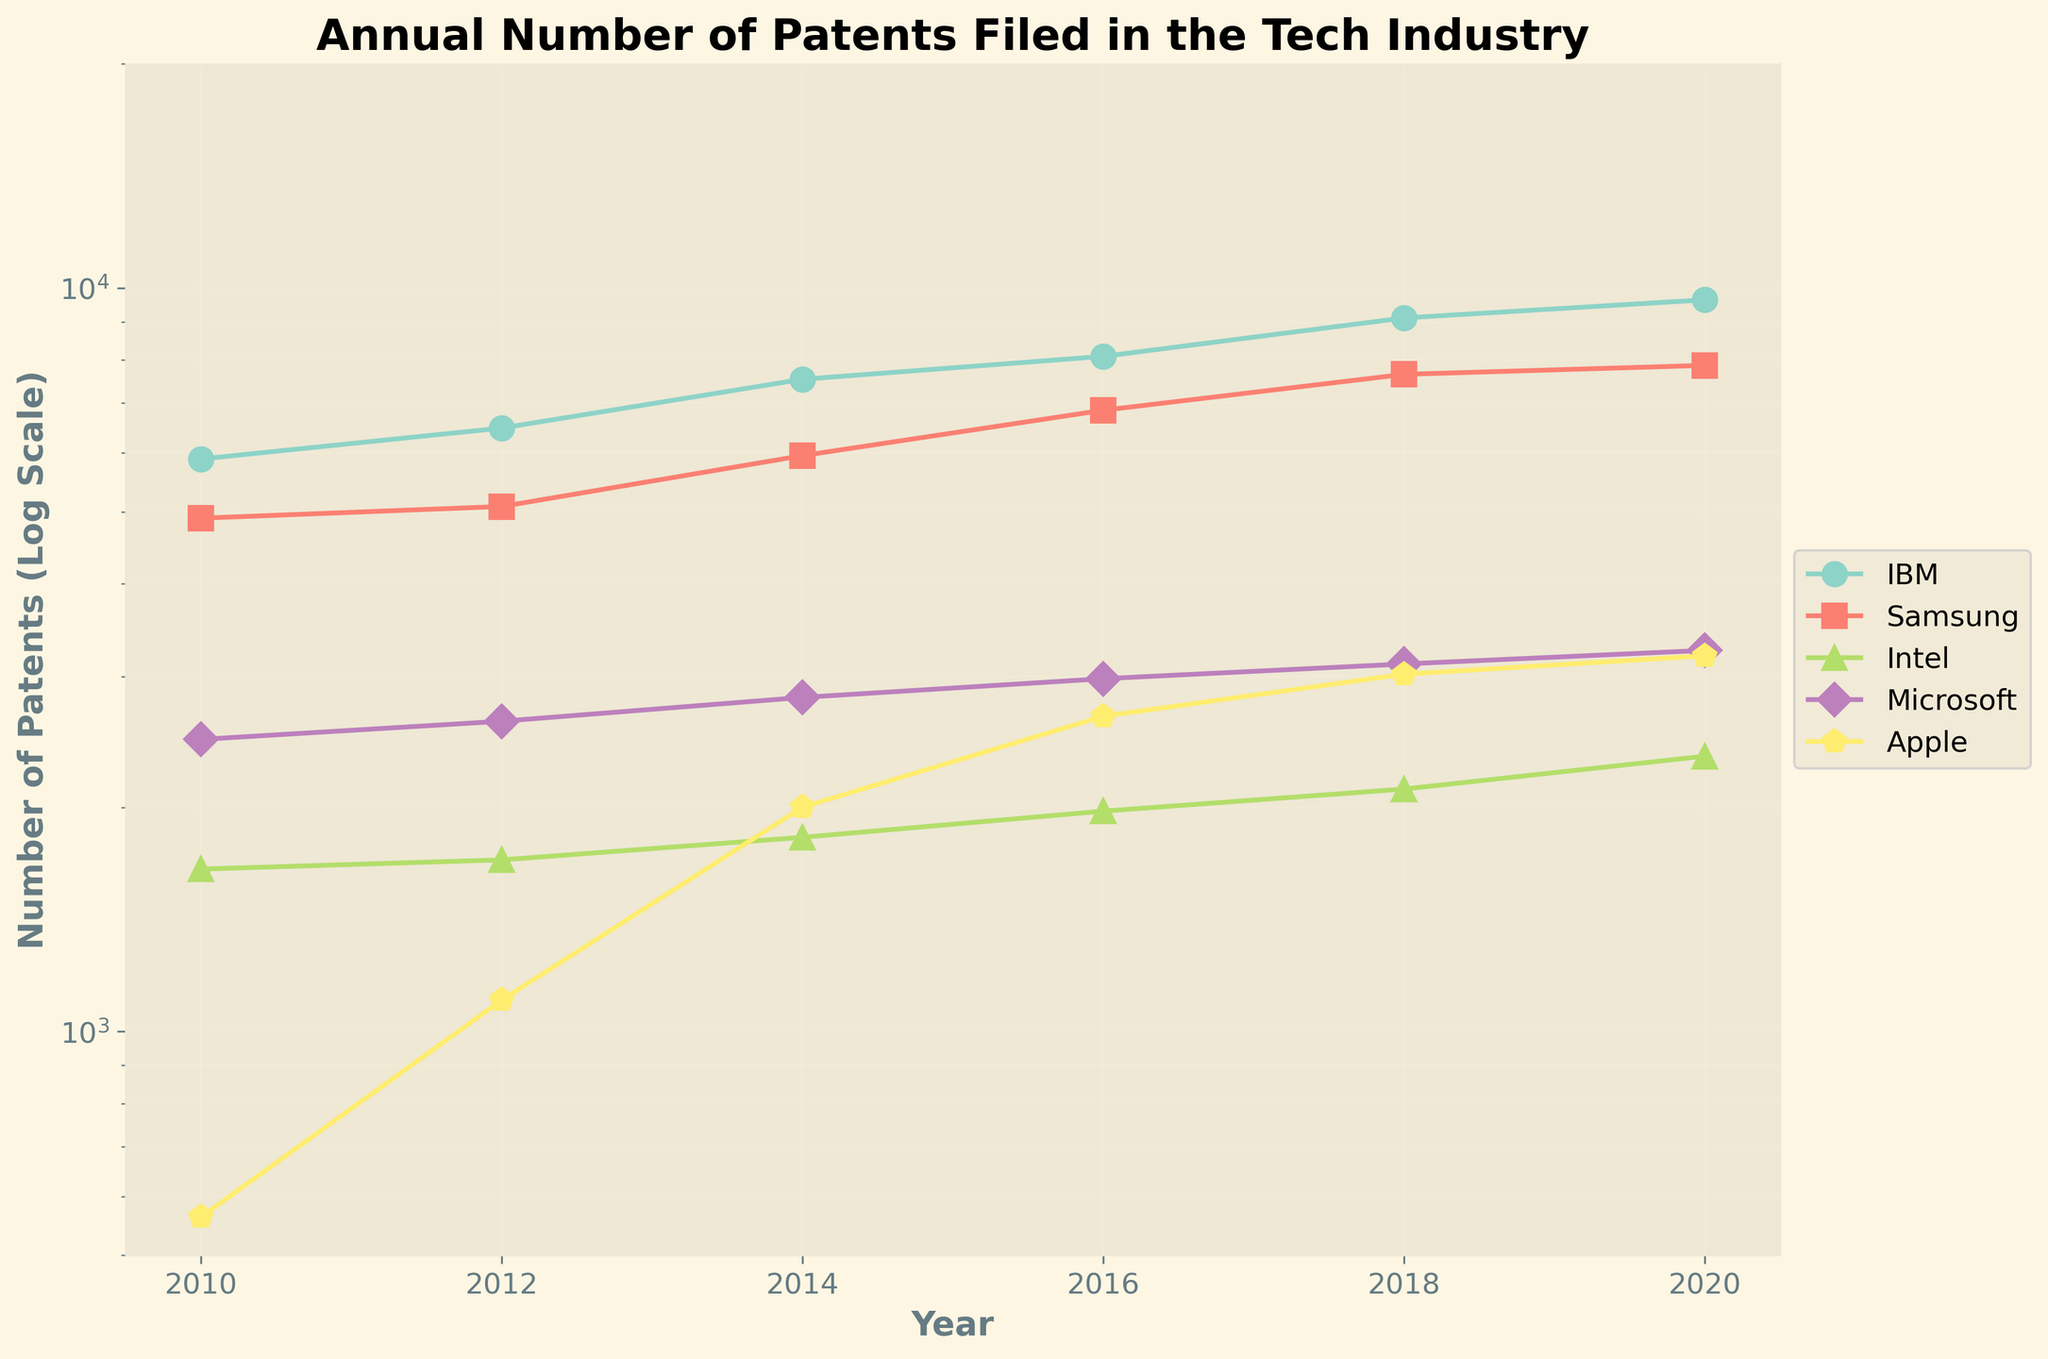what is the title of the figure? The title is usually displayed at the top of the figure in larger font. This title indicates the main subject or purpose of the figure.
Answer: Annual Number of Patents Filed in the Tech Industry What is the y-axis scale of this plot? The y-axis scale can usually be determined by looking at the ticks and axis label. In this plot, it is mentioned that the y-axis is on a log scale.
Answer: Log scale How many companies are represented in this figure based on the legend? To determine the number of companies, look at the legend, which lists each company with its corresponding color and marker.
Answer: 5 Which company had the highest number of patents filed in 2020 based on the plot? By looking at the log-scaled y-axis values for the year 2020, you can compare which company has the highest data point.
Answer: IBM What is the trend of patents filed by Apple from 2010 to 2020? Analyze the position of Apple’s data points over the years; note any increases or stable trends along the y-axis for Apple.
Answer: Increasing Which company had the largest increase in the number of patents filed between 2010 and 2020? Calculate the difference between the patents filed in 2020 and 2010 for each company and compare these differences.
Answer: IBM For the year 2016, which two companies have the closest number of patents filed? Compare the y-axis values for all companies in 2016 and identify which two are closest in value.
Answer: Microsoft and Intel What is the average number of patents filed by Microsoft in the years provided? Sum the number of patents filed by Microsoft across the years and divide by the number of years. (2470 + 2613 + 2813 + 2981 + 3120 + 3254) / 6 = 2875.167
Answer: 2875.167 What is the ratio of the number of patents filed by IBM to Intel in 2020? Divide the number of patents filed by IBM by the number of patents filed by Intel in 2020. 9635 / 2345
Answer: 4.1 By what factor did the number of patents filed by Samsung increase from 2010 to 2020? Divide the number of patents filed by Samsung in 2020 by the number filed in 2010. 7865 / 4900
Answer: 1.6 